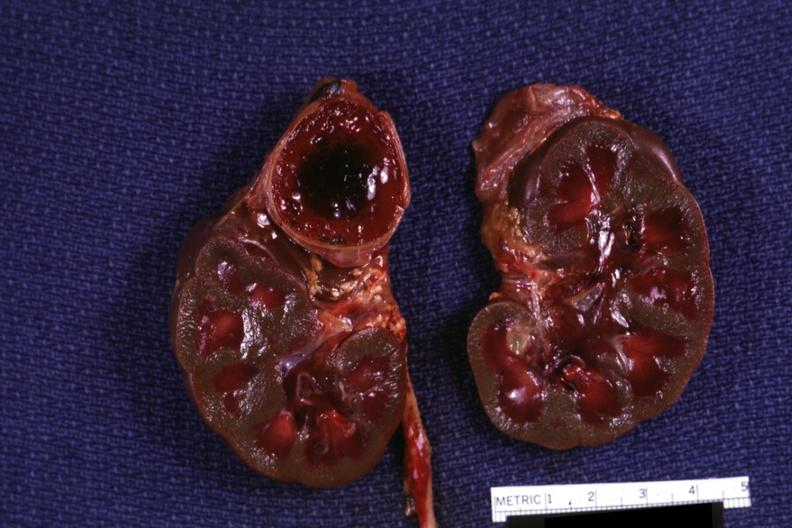how many side does this image show section of both kidneys and adrenals hemorrhage on kidneys are jaundiced?
Answer the question using a single word or phrase. One 